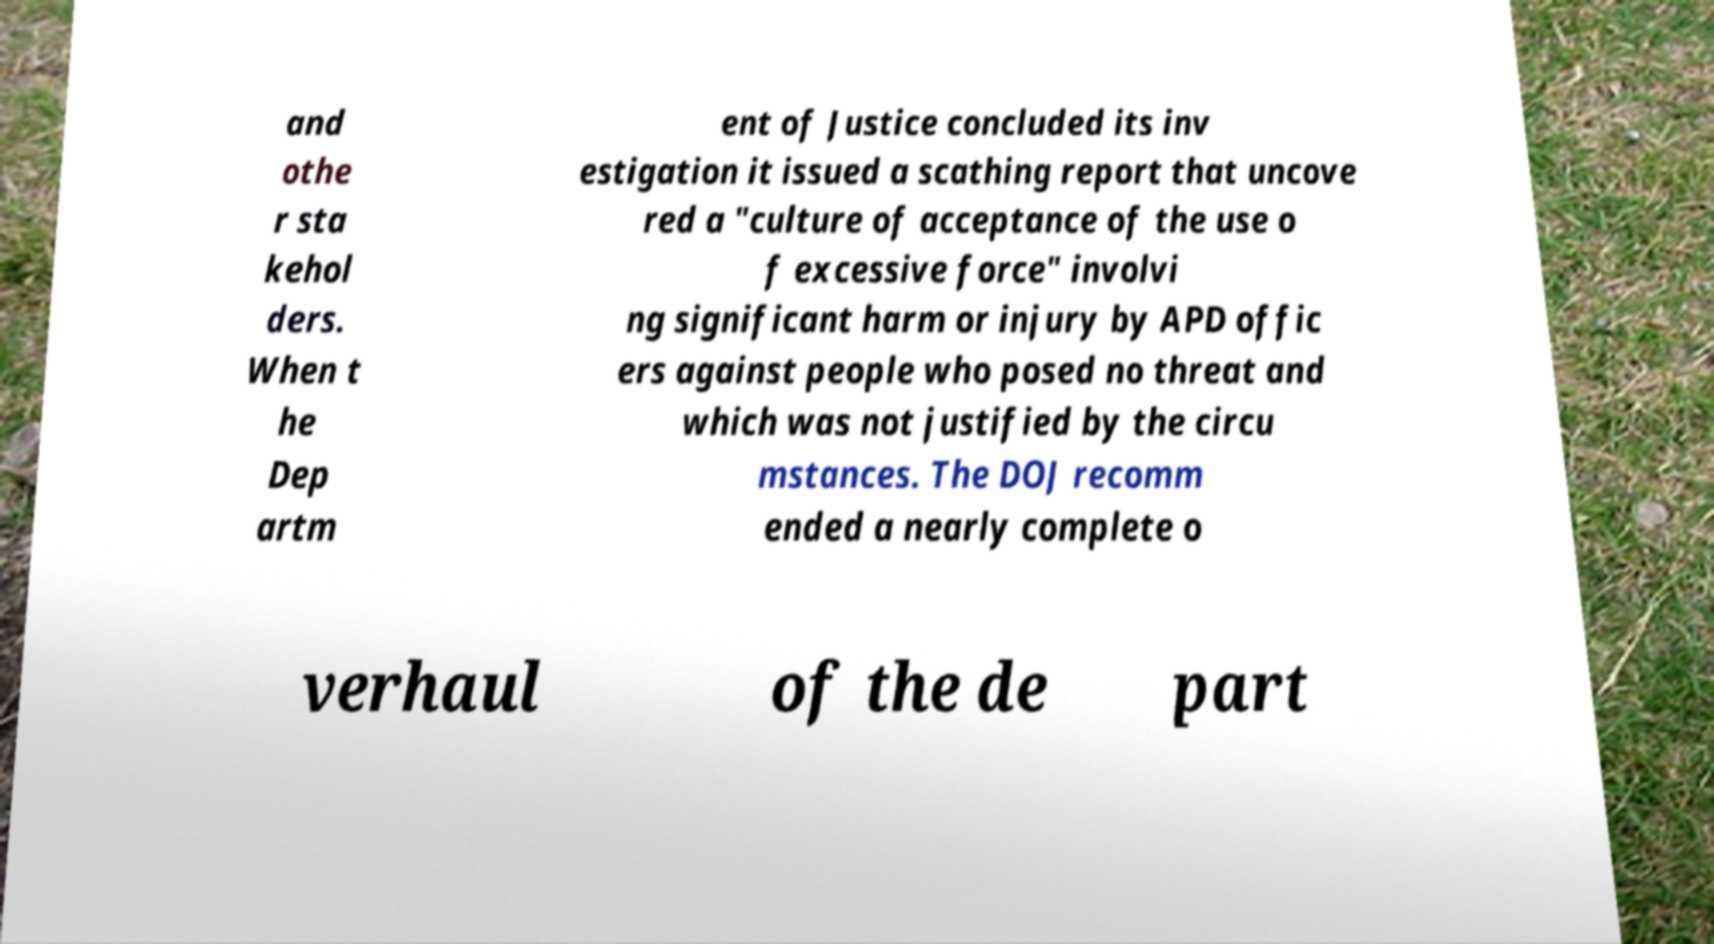Please read and relay the text visible in this image. What does it say? and othe r sta kehol ders. When t he Dep artm ent of Justice concluded its inv estigation it issued a scathing report that uncove red a "culture of acceptance of the use o f excessive force" involvi ng significant harm or injury by APD offic ers against people who posed no threat and which was not justified by the circu mstances. The DOJ recomm ended a nearly complete o verhaul of the de part 